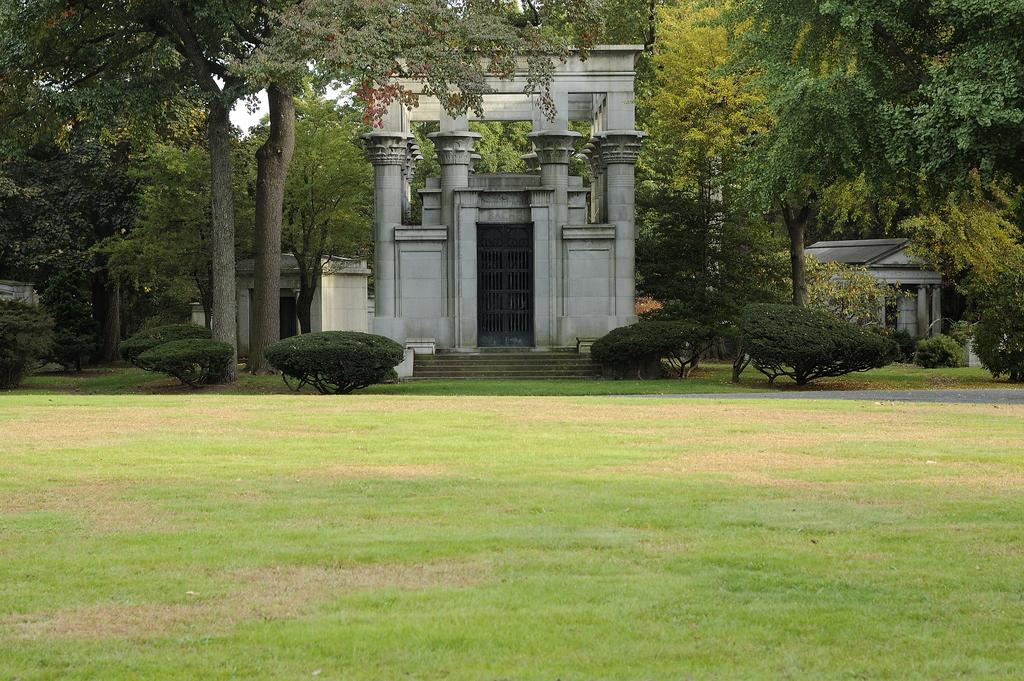What type of vegetation can be seen in the image? There is grass, plants, and trees in the image. What type of structures are present in the image? There are houses and pillars in the image. What architectural feature can be seen in the image? There is a door in the image. What is visible in the background of the image? The sky is visible in the background of the image. How many girls are holding a locket in the image? There are no girls or lockets present in the image. What is the middle of the image occupied by? The provided facts do not specify the middle of the image, so it cannot be determined from the information given. 